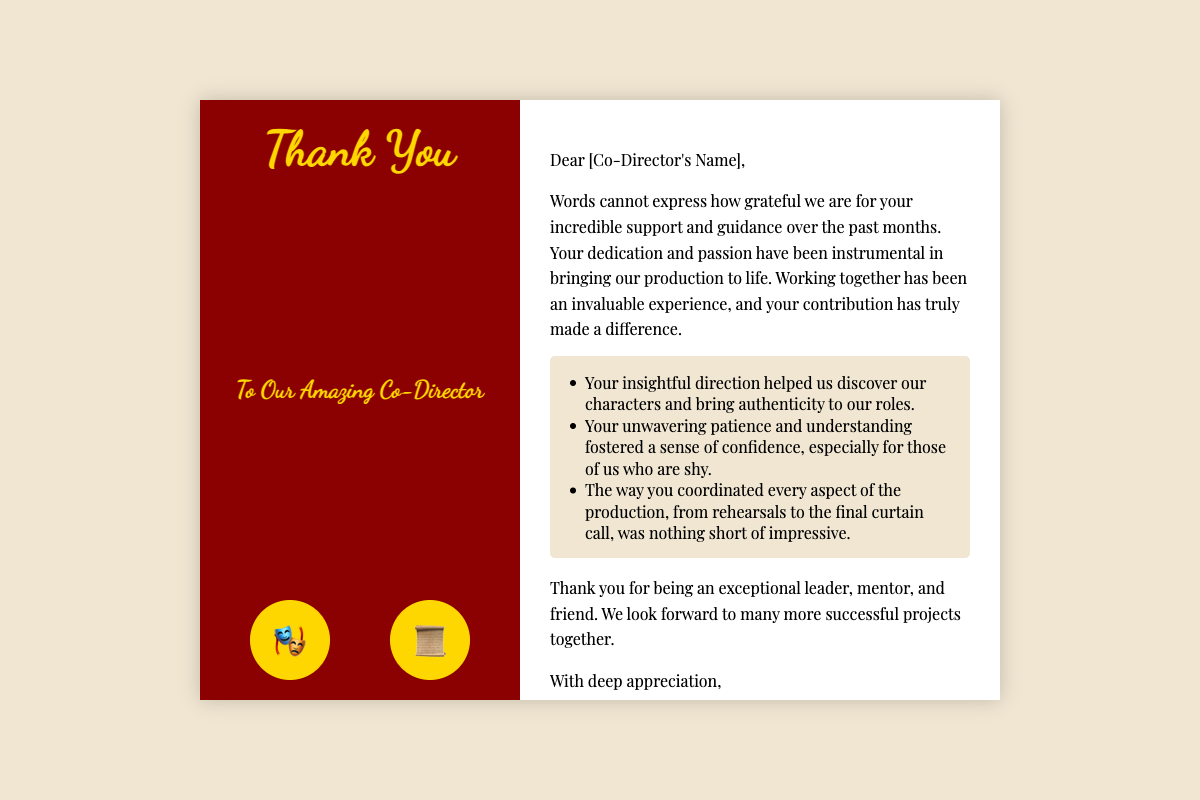What is the title of the card? The title of the card is stated prominently on the cover, indicating its purpose.
Answer: Thank You Who is the card addressed to? The card is addressed to an individual who has been instrumental in the production, as indicated in the greeting.
Answer: Our Amazing Co-Director What symbols are included on the cover? The cover features two specific symbols that reflect the theme of the theater.
Answer: 🎭, 📜 What is one highlighted quality of the co-director? The document lists specific qualities of the co-director in a highlight section, which demonstrates their significance in the production.
Answer: Insightful direction How does the sender feel about the co-director's contribution? The document conveys strong emotions regarding the co-director's involvement and the impact it has had on the production.
Answer: Grateful How is the closing signed in the card? The card ends with a specific sign-off that includes the name of the sender and the group they represent.
Answer: [Your Name], The Cast and Crew of [Production Name] 